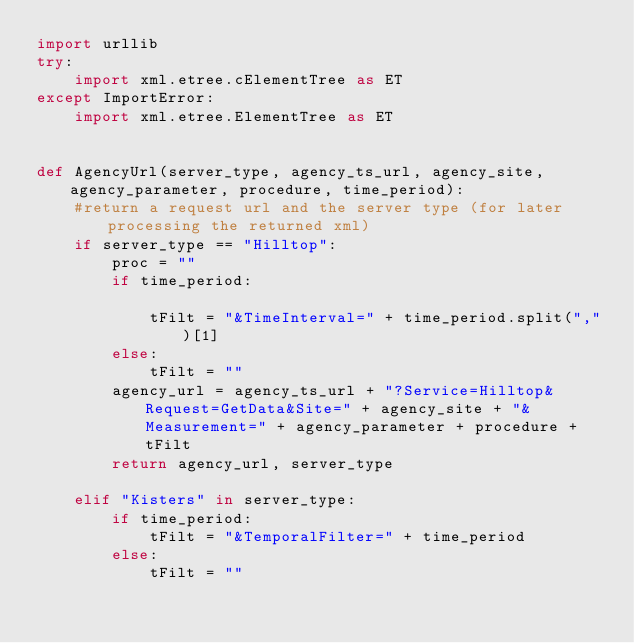Convert code to text. <code><loc_0><loc_0><loc_500><loc_500><_Python_>import urllib
try:
    import xml.etree.cElementTree as ET
except ImportError:
    import xml.etree.ElementTree as ET


def AgencyUrl(server_type, agency_ts_url, agency_site, agency_parameter, procedure, time_period):
    #return a request url and the server type (for later processing the returned xml)
    if server_type == "Hilltop":
        proc = ""
        if time_period:

            tFilt = "&TimeInterval=" + time_period.split(",")[1]
        else:
            tFilt = ""
        agency_url = agency_ts_url + "?Service=Hilltop&Request=GetData&Site=" + agency_site + "&Measurement=" + agency_parameter + procedure + tFilt
        return agency_url, server_type

    elif "Kisters" in server_type:
        if time_period:
            tFilt = "&TemporalFilter=" + time_period
        else:
            tFilt = ""</code> 